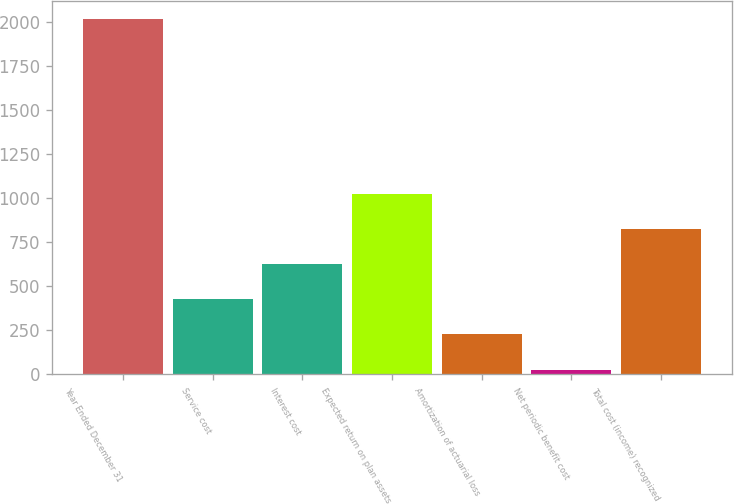Convert chart to OTSL. <chart><loc_0><loc_0><loc_500><loc_500><bar_chart><fcel>Year Ended December 31<fcel>Service cost<fcel>Interest cost<fcel>Expected return on plan assets<fcel>Amortization of actuarial loss<fcel>Net periodic benefit cost<fcel>Total cost (income) recognized<nl><fcel>2017<fcel>425.8<fcel>624.7<fcel>1022.5<fcel>226.9<fcel>28<fcel>823.6<nl></chart> 